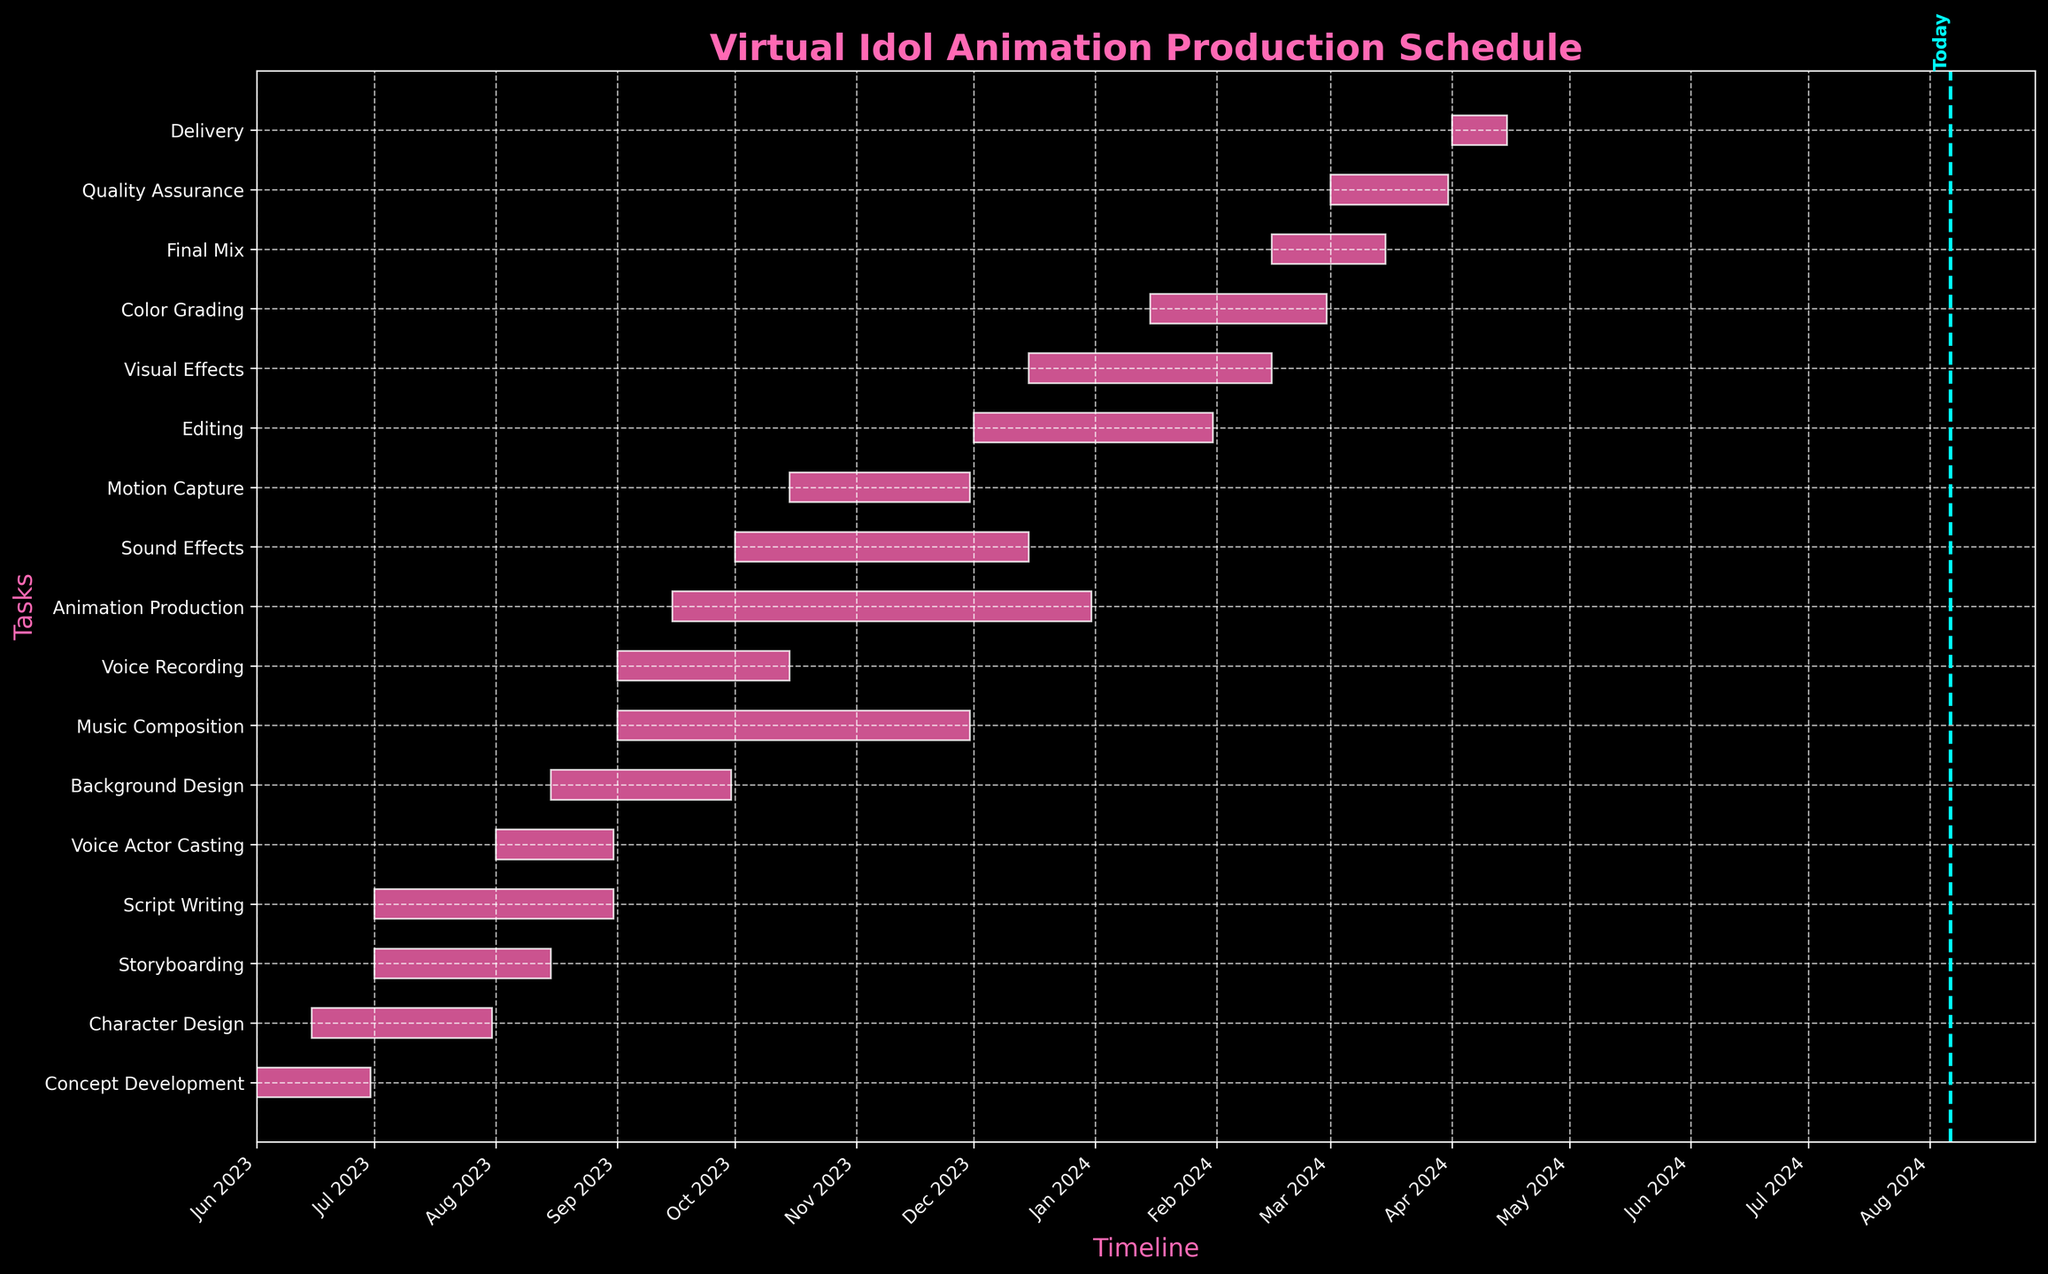What is the title of the Gantt chart? The title of a chart is typically found at the top of the figure. In this case, it's bold and colored in pink, stating the main focus of the chart.
Answer: Virtual Idol Animation Production Schedule What is the first task in the production schedule? The tasks are sorted by start date, and the first y-axis label at the top represents the earliest task.
Answer: Concept Development How long does the Character Design phase last? To find the length of a phase, look at the start and end dates of the respective task bar. The Character Design phase starts on June 15, 2023, and ends on July 31, 2023.
Answer: 47 days Which task takes the longest to complete? Observe the length of the bars; the longest bar represents the task that takes the most time to complete.
Answer: Animation Production How many tasks run during September 2023? Identify the bars that intersect with the timeline of September 2023. These tasks include Voice Recording, Background Design, Animation Production, and Music Composition.
Answer: 4 tasks What tasks are overlapping with Voice Recording? Locate the Voice Recording bar and identify other tasks that start or end within its timeline. Overlapping tasks include Background Design, Animation Production, and Music Composition.
Answer: 3 tasks Which task ends last? The bar that extends the furthest right on the timeline represents the task that ends last.
Answer: Delivery How long is the gap between the end of Background Design and the start of Editing? Background Design ends on September 30, 2023, and Editing starts on December 1, 2023. Calculate the days between these dates.
Answer: 62 days What phases are on-going today? Observe the vertical line indicating today's date. Any task bar that intersects with this line is on-going.
Answer: Animation Production and Sound Effects Which task has the same duration as Concept Development? Concept Development lasts for 30 days. Find another bar with the same length.
Answer: Final Mix 